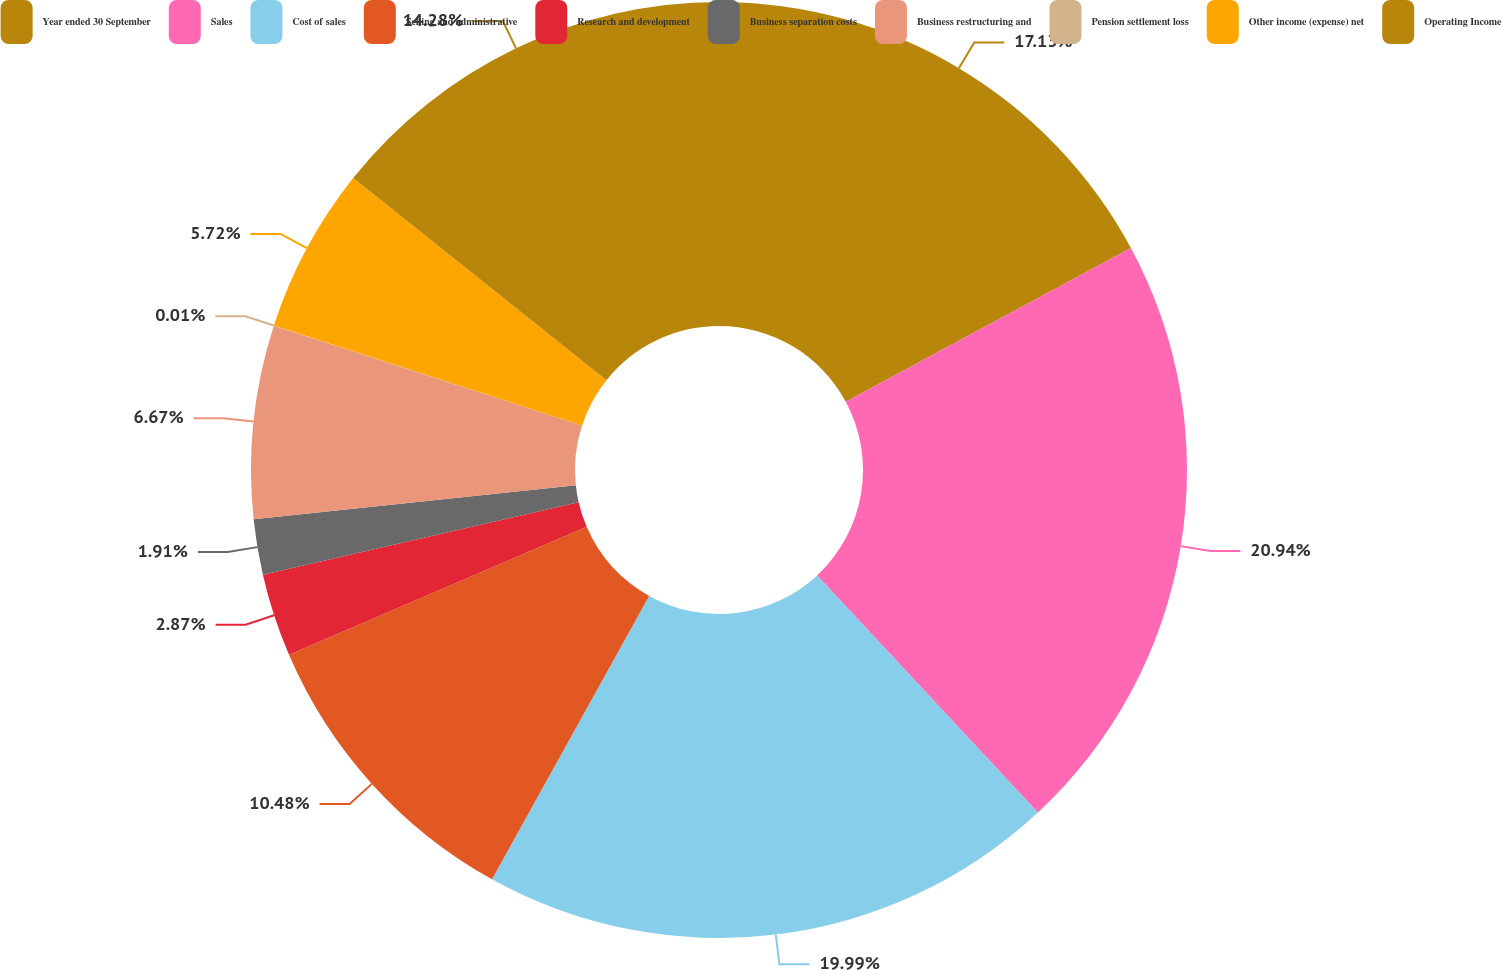Convert chart. <chart><loc_0><loc_0><loc_500><loc_500><pie_chart><fcel>Year ended 30 September<fcel>Sales<fcel>Cost of sales<fcel>Selling and administrative<fcel>Research and development<fcel>Business separation costs<fcel>Business restructuring and<fcel>Pension settlement loss<fcel>Other income (expense) net<fcel>Operating Income<nl><fcel>17.13%<fcel>20.94%<fcel>19.99%<fcel>10.48%<fcel>2.87%<fcel>1.91%<fcel>6.67%<fcel>0.01%<fcel>5.72%<fcel>14.28%<nl></chart> 